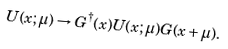Convert formula to latex. <formula><loc_0><loc_0><loc_500><loc_500>U ( x ; \mu ) \rightarrow G ^ { \dagger } ( x ) U ( x ; \mu ) G ( x + \mu ) .</formula> 